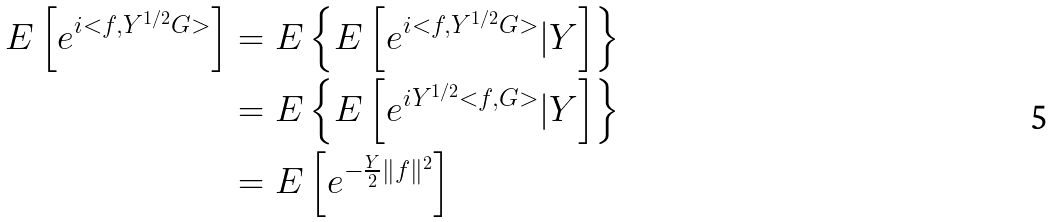<formula> <loc_0><loc_0><loc_500><loc_500>E \left [ e ^ { i < f , Y ^ { 1 / 2 } G > } \right ] & = E \left \{ E \left [ e ^ { i < f , Y ^ { 1 / 2 } G > } | Y \right ] \right \} \\ & = E \left \{ E \left [ e ^ { i Y ^ { 1 / 2 } < f , G > } | Y \right ] \right \} \\ & = E \left [ e ^ { - \frac { Y } { 2 } \| f \| ^ { 2 } } \right ]</formula> 